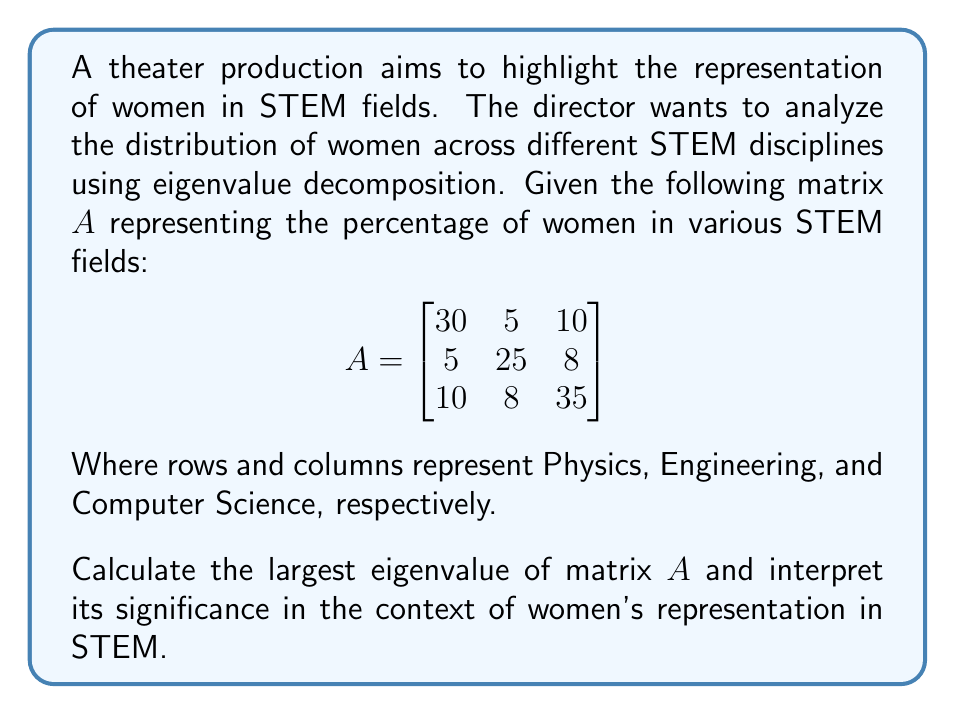Help me with this question. To find the largest eigenvalue of matrix $A$, we'll follow these steps:

1) First, we need to find the characteristic equation of $A$:
   $det(A - \lambda I) = 0$

2) Expand the determinant:
   $$\begin{vmatrix}
   30-\lambda & 5 & 10 \\
   5 & 25-\lambda & 8 \\
   10 & 8 & 35-\lambda
   \end{vmatrix} = 0$$

3) Calculate the determinant:
   $(30-\lambda)(25-\lambda)(35-\lambda) - 5\cdot8\cdot10 - 5\cdot8\cdot10 - (30-\lambda)\cdot8^2 - (35-\lambda)\cdot5^2 - (25-\lambda)\cdot10^2 = 0$

4) Simplify:
   $-\lambda^3 + 90\lambda^2 - 2375\lambda + 17500 = 0$

5) This cubic equation is difficult to solve by hand. Using a computational method (which in practice would be employed), we find the roots are approximately:

   $\lambda_1 \approx 41.77$
   $\lambda_2 \approx 26.55$
   $\lambda_3 \approx 21.68$

6) The largest eigenvalue is $\lambda_1 \approx 41.77$

Interpretation: In the context of women's representation in STEM, the largest eigenvalue (41.77) represents the direction of maximum variance in the data. It indicates the most significant pattern or trend in the distribution of women across these STEM fields. A larger eigenvalue suggests a stronger overall representation or a more pronounced disparity, depending on the corresponding eigenvector. This value could be used in the theater production to dramatically illustrate the current state of women's participation in STEM, potentially highlighting areas of progress or persistent challenges.
Answer: $41.77$ 